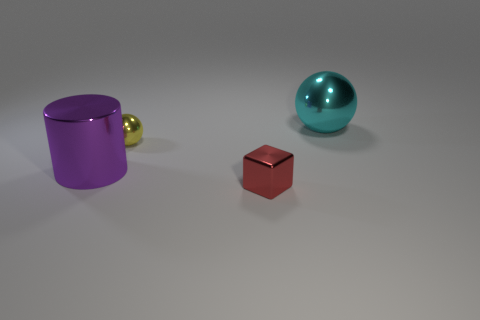Add 1 tiny gray metallic things. How many objects exist? 5 Subtract all blocks. How many objects are left? 3 Subtract all big purple objects. Subtract all small brown metal balls. How many objects are left? 3 Add 1 small yellow spheres. How many small yellow spheres are left? 2 Add 4 purple metal cylinders. How many purple metal cylinders exist? 5 Subtract 0 green spheres. How many objects are left? 4 